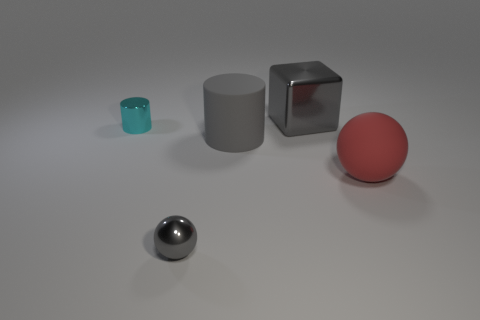The large block is what color?
Offer a terse response. Gray. Is the material of the big sphere the same as the object that is behind the tiny cyan shiny cylinder?
Your answer should be very brief. No. There is a small gray thing that is made of the same material as the large gray cube; what is its shape?
Make the answer very short. Sphere. What color is the metal thing that is the same size as the gray ball?
Provide a short and direct response. Cyan. There is a shiny object in front of the cyan cylinder; is it the same size as the small cylinder?
Give a very brief answer. Yes. Is the color of the big block the same as the tiny metal sphere?
Keep it short and to the point. Yes. How many gray balls are there?
Give a very brief answer. 1. What number of blocks are either metal things or big shiny things?
Keep it short and to the point. 1. What number of big balls are to the right of the gray object that is behind the metal cylinder?
Offer a terse response. 1. Is the material of the block the same as the red object?
Your answer should be compact. No. 